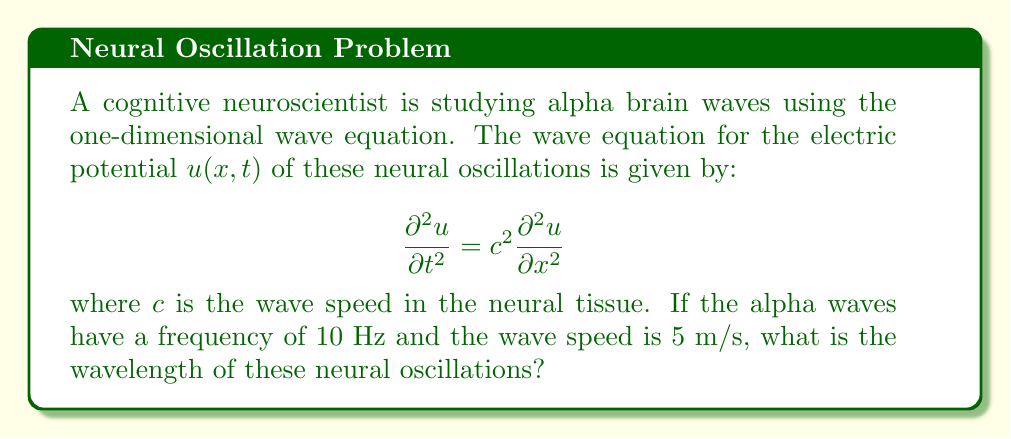Give your solution to this math problem. To solve this problem, we'll use the relationship between wave speed, frequency, and wavelength. The steps are as follows:

1) Recall the wave equation: $c = f\lambda$
   where $c$ is the wave speed, $f$ is the frequency, and $\lambda$ is the wavelength.

2) We are given:
   $c = 5$ m/s (wave speed)
   $f = 10$ Hz (frequency)

3) Rearrange the equation to solve for $\lambda$:
   $\lambda = \frac{c}{f}$

4) Substitute the known values:
   $\lambda = \frac{5 \text{ m/s}}{10 \text{ Hz}}$

5) Simplify:
   $\lambda = 0.5$ m

Therefore, the wavelength of the alpha brain waves is 0.5 meters.
Answer: $0.5$ m 